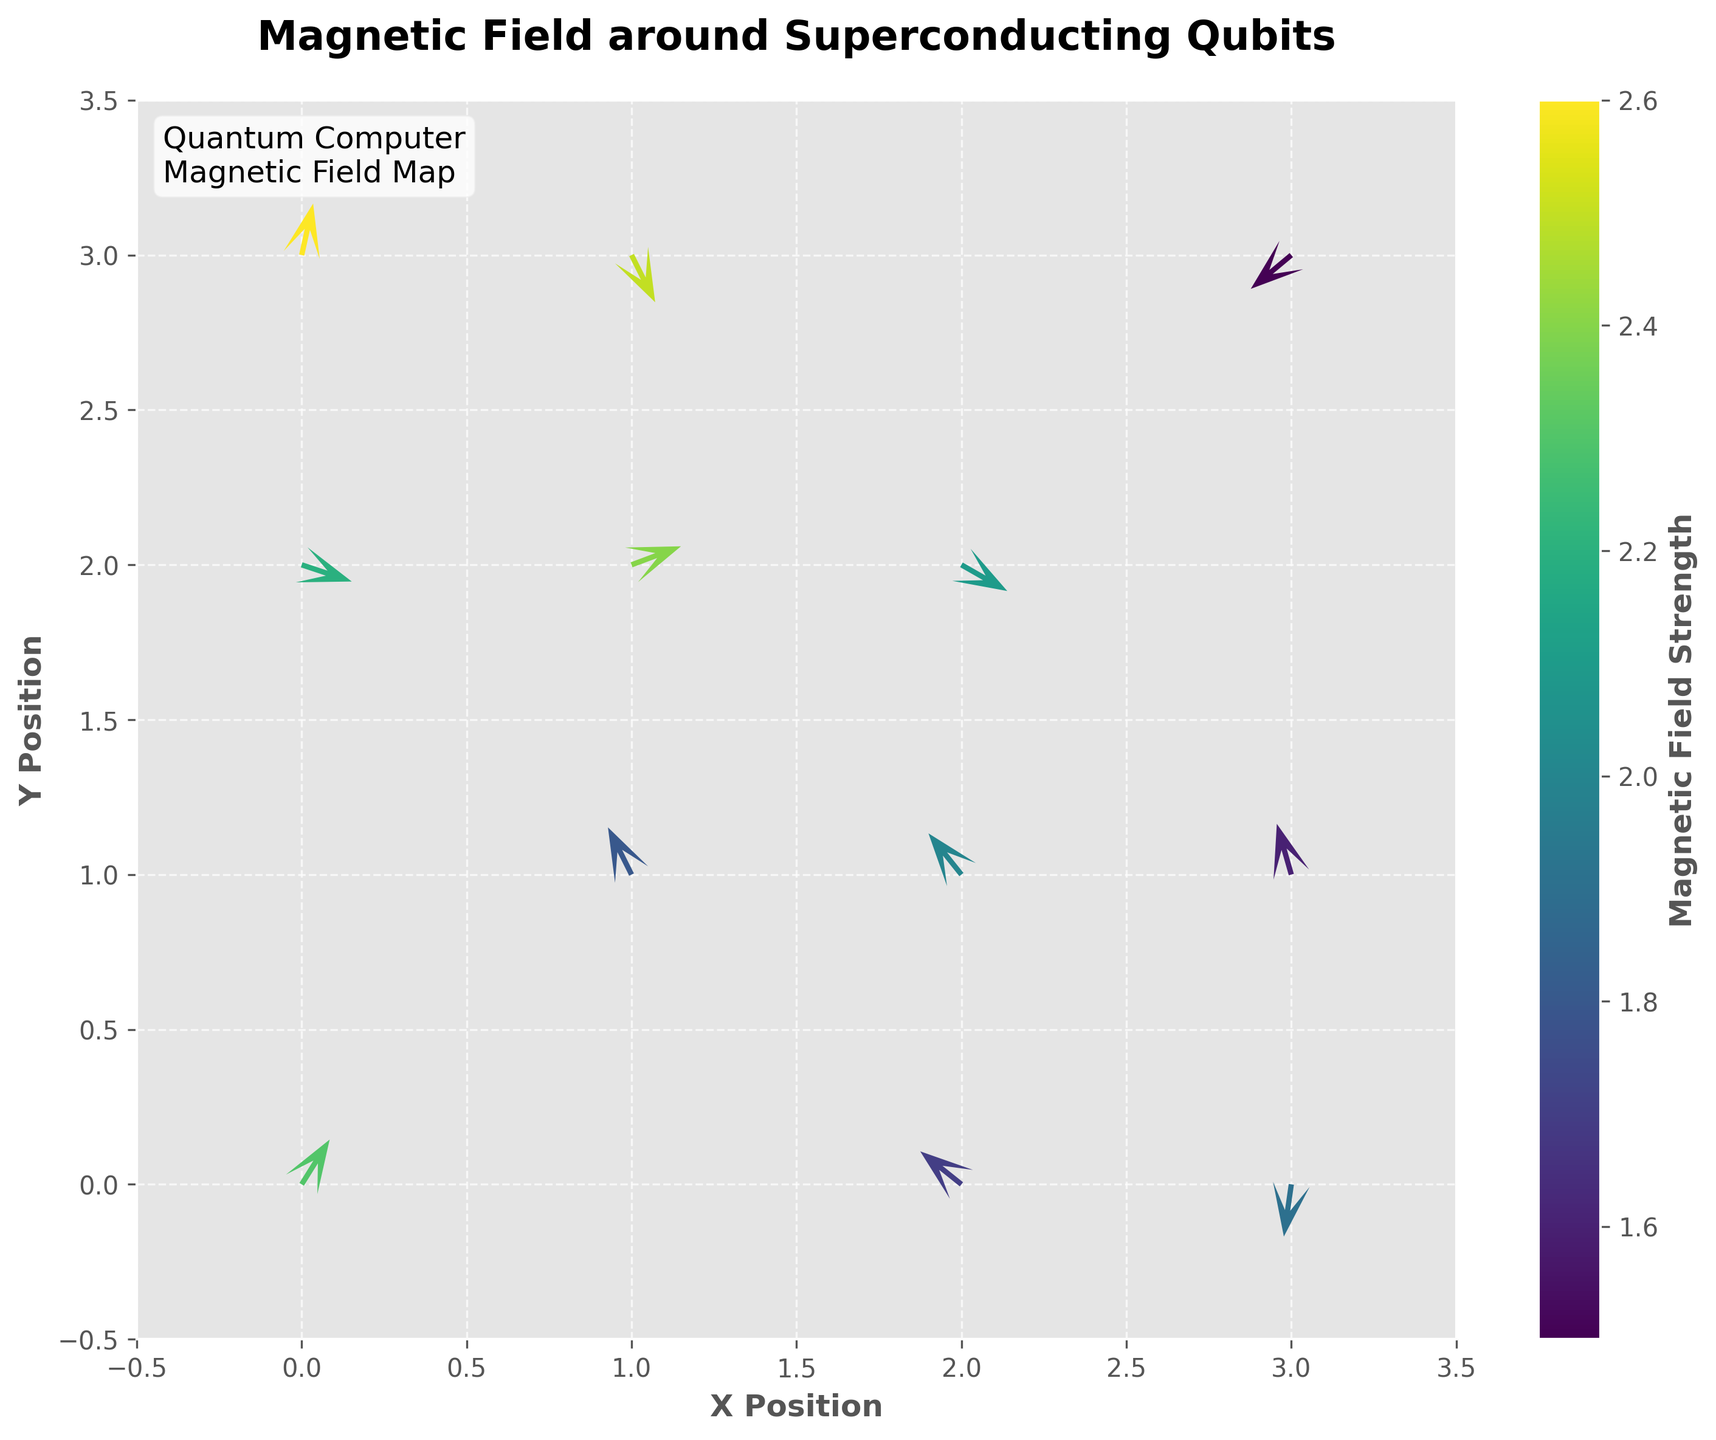What is the title of the plot? The title of the plot is displayed at the top and is usually in larger and bold text for emphasis. In this figure, it reads "Magnetic Field around Superconducting Qubits".
Answer: Magnetic Field around Superconducting Qubits What do the color variations in the arrows represent? The color variations in the arrows are shown by the colorbar on the right side of the plot. According to the label, the colors represent the strength of the magnetic field, with darker colors possibly indicating lower strengths and lighter colors indicating higher strengths.
Answer: Magnetic field strength How many data points are represented in the plot? To find the number of data points, count the number of arrow heads depicted in the plot. In the dataset, there are 12 rows, meaning there are 12 data points, each corresponding to an arrow in the plot.
Answer: 12 Which position shows the strongest magnetic field strength? To find the position with the strongest magnetic field strength, look at the color of the arrows and find the one corresponding to the highest value on the colorbar. The position (0, 3) has the highest strength of 2.6.
Answer: (0, 3) Which direction does the arrow at position (3, 1) point? Observe the direction of the arrowhead at position (3, 1). In this plot, the arrow at (3, 1) points upward to the right, indicating a direction of (-0.2, 0.7).
Answer: Upward to the right Which data points have the magnetic field strength greater than 2.0 but less than or equal to 2.5? Check the color of the arrows and cross-reference with the magnetic field strengths on the colorbar. The positions that meet the criteria are (0, 0), (2, 2), (0, 2), (2, 1), and (1, 3).
Answer: (0, 0), (2, 2), (0, 2), (2, 1), (1, 3) What is the average magnetic field strength of all data points? Sum all the magnetic field strengths from the data points and divide by the number of points: (2.3 + 1.8 + 2.1 + 1.5 + 2.6 + 1.9 + 2.4 + 2.0 + 2.2 + 1.7 + 2.5 + 1.6) / 12 = 24.6 / 12 = 2.05.
Answer: 2.05 Which two data points have arrows with opposite directions? Observing the direction of the arrows, the arrows at positions (2, 2) and (1, 1) point in opposite directions: (0.7, -0.4) and (-0.3, 0.6).
Answer: (2, 2) and (1, 1) What is the direction and length of the arrow at position (1, 2)? The arrow at position (1, 2) points upward to the right with direction (0.8, 0.3). The length of this arrow can be calculated using sqrt(0.8^2 + 0.3^2), which equals approximately 0.854.
Answer: Upward to the right, approximately 0.854 Which position has an arrow pointing most directly downward? Among the downward-pointing arrows, the position (3, 0) with the direction vector (-0.1, -0.7) shows the most vertically downward orientation.
Answer: (3, 0) 